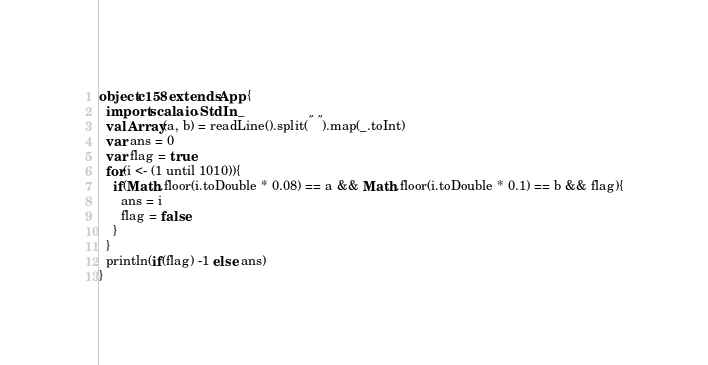Convert code to text. <code><loc_0><loc_0><loc_500><loc_500><_Scala_>object c158 extends App {
  import scala.io.StdIn._
  val Array(a, b) = readLine().split(" ").map(_.toInt)
  var ans = 0
  var flag = true
  for(i <- (1 until 1010)){
    if(Math.floor(i.toDouble * 0.08) == a && Math.floor(i.toDouble * 0.1) == b && flag){
      ans = i
      flag = false
    }
  }
  println(if(flag) -1 else ans)
}</code> 